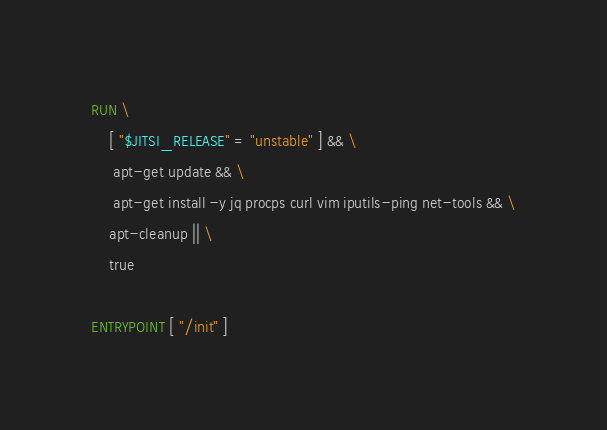Convert code to text. <code><loc_0><loc_0><loc_500><loc_500><_Dockerfile_>
RUN \
	[ "$JITSI_RELEASE" = "unstable" ] && \
	 apt-get update && \
	 apt-get install -y jq procps curl vim iputils-ping net-tools && \
	apt-cleanup || \
	true

ENTRYPOINT [ "/init" ]
</code> 